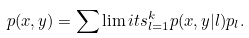<formula> <loc_0><loc_0><loc_500><loc_500>p ( x , y ) = \sum \lim i t s _ { l = 1 } ^ { k } p ( x , y | l ) p _ { l } .</formula> 